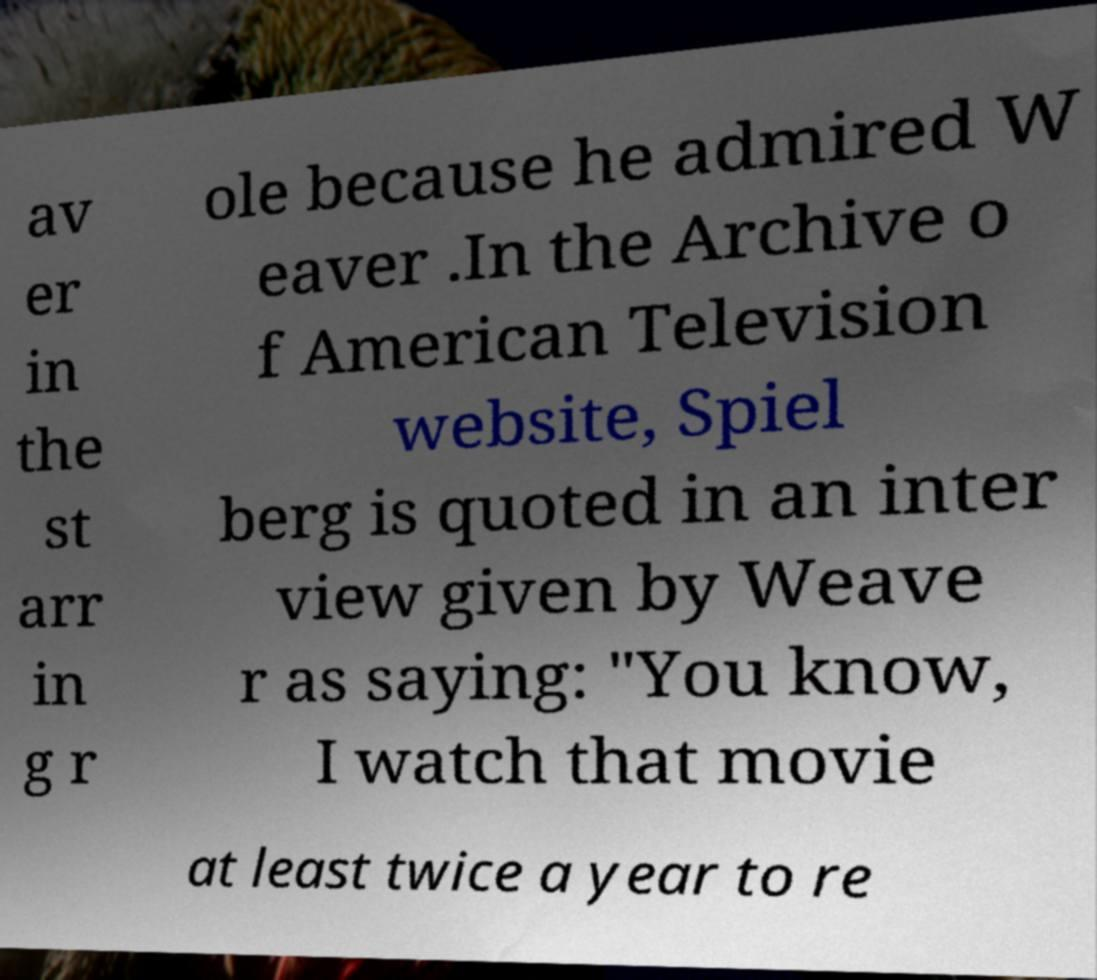I need the written content from this picture converted into text. Can you do that? av er in the st arr in g r ole because he admired W eaver .In the Archive o f American Television website, Spiel berg is quoted in an inter view given by Weave r as saying: "You know, I watch that movie at least twice a year to re 